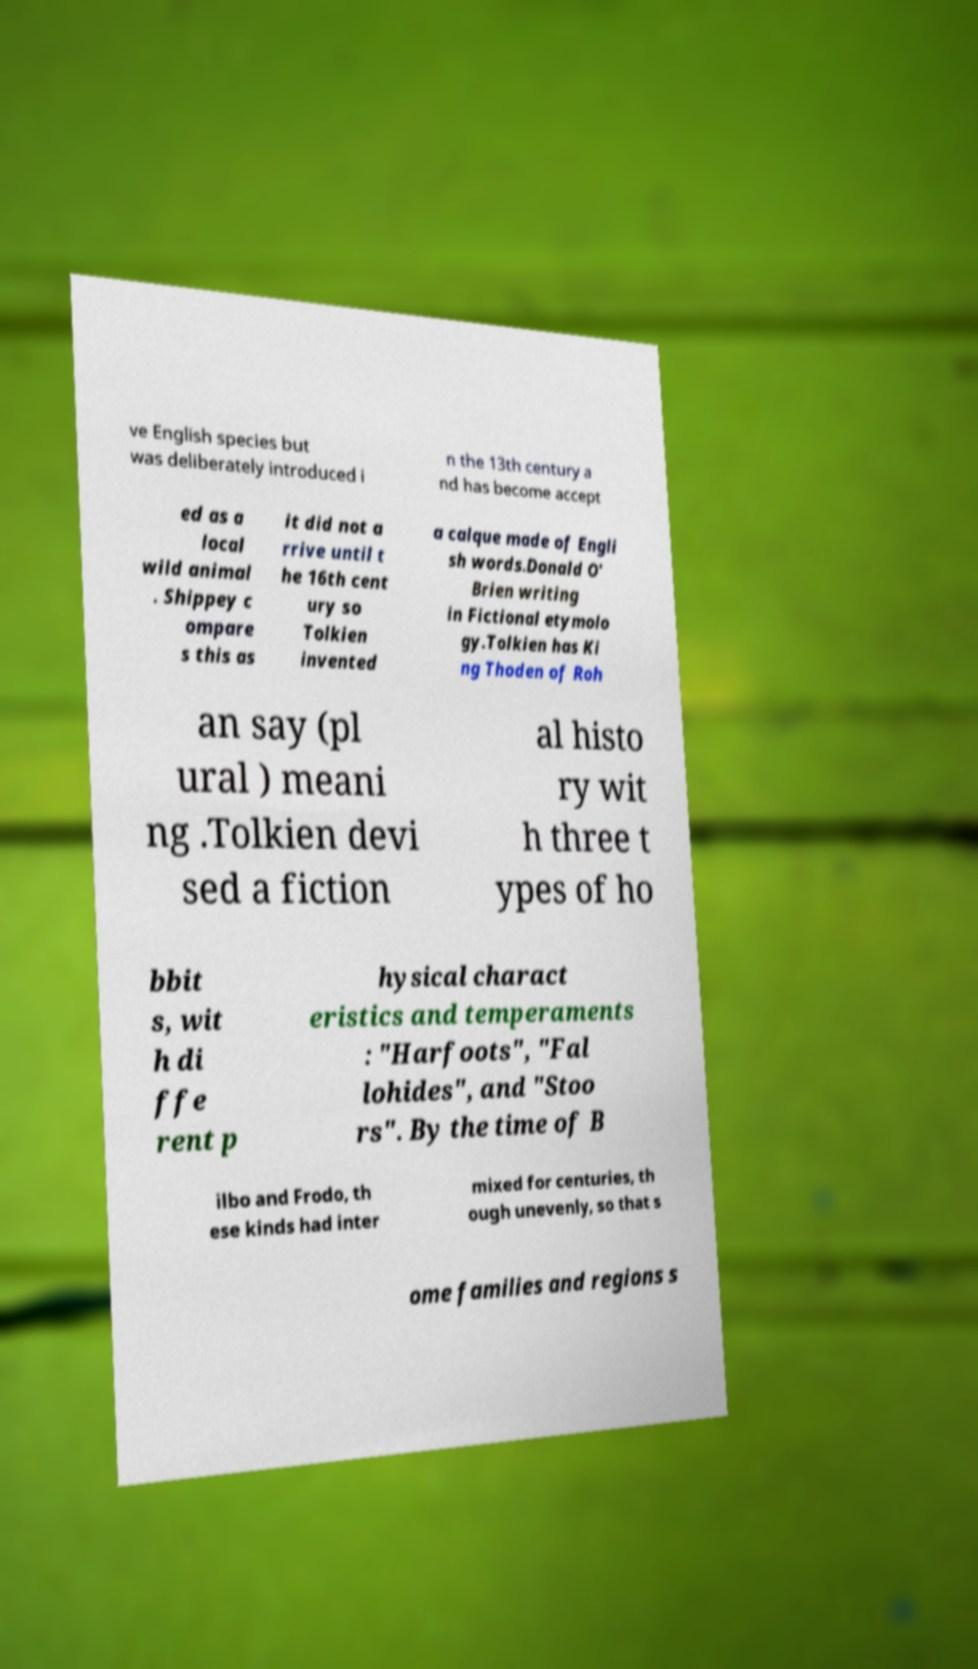Can you accurately transcribe the text from the provided image for me? ve English species but was deliberately introduced i n the 13th century a nd has become accept ed as a local wild animal . Shippey c ompare s this as it did not a rrive until t he 16th cent ury so Tolkien invented a calque made of Engli sh words.Donald O' Brien writing in Fictional etymolo gy.Tolkien has Ki ng Thoden of Roh an say (pl ural ) meani ng .Tolkien devi sed a fiction al histo ry wit h three t ypes of ho bbit s, wit h di ffe rent p hysical charact eristics and temperaments : "Harfoots", "Fal lohides", and "Stoo rs". By the time of B ilbo and Frodo, th ese kinds had inter mixed for centuries, th ough unevenly, so that s ome families and regions s 